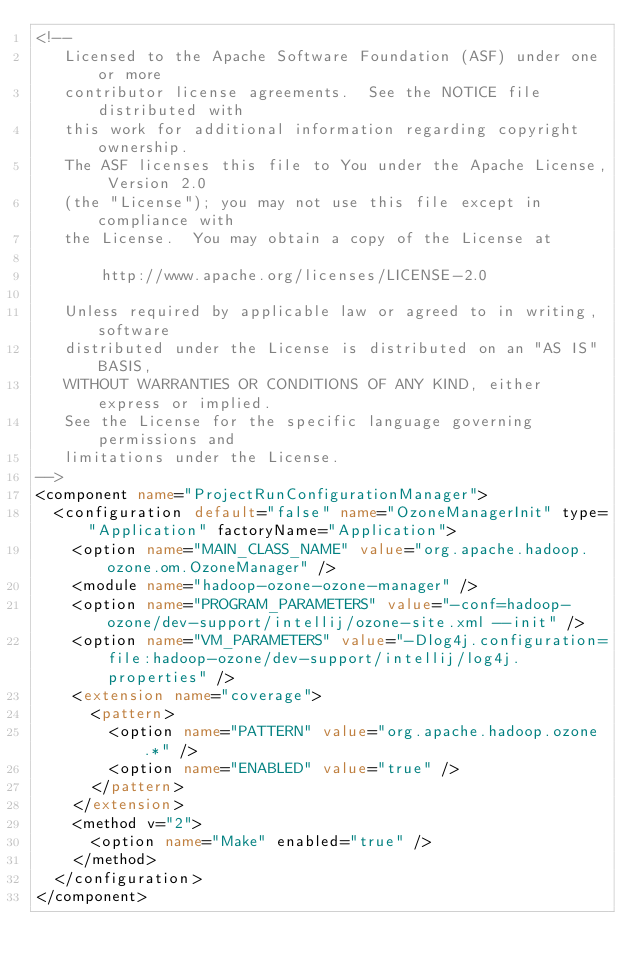<code> <loc_0><loc_0><loc_500><loc_500><_XML_><!--
   Licensed to the Apache Software Foundation (ASF) under one or more
   contributor license agreements.  See the NOTICE file distributed with
   this work for additional information regarding copyright ownership.
   The ASF licenses this file to You under the Apache License, Version 2.0
   (the "License"); you may not use this file except in compliance with
   the License.  You may obtain a copy of the License at

       http://www.apache.org/licenses/LICENSE-2.0

   Unless required by applicable law or agreed to in writing, software
   distributed under the License is distributed on an "AS IS" BASIS,
   WITHOUT WARRANTIES OR CONDITIONS OF ANY KIND, either express or implied.
   See the License for the specific language governing permissions and
   limitations under the License.
-->
<component name="ProjectRunConfigurationManager">
  <configuration default="false" name="OzoneManagerInit" type="Application" factoryName="Application">
    <option name="MAIN_CLASS_NAME" value="org.apache.hadoop.ozone.om.OzoneManager" />
    <module name="hadoop-ozone-ozone-manager" />
    <option name="PROGRAM_PARAMETERS" value="-conf=hadoop-ozone/dev-support/intellij/ozone-site.xml --init" />
    <option name="VM_PARAMETERS" value="-Dlog4j.configuration=file:hadoop-ozone/dev-support/intellij/log4j.properties" />
    <extension name="coverage">
      <pattern>
        <option name="PATTERN" value="org.apache.hadoop.ozone.*" />
        <option name="ENABLED" value="true" />
      </pattern>
    </extension>
    <method v="2">
      <option name="Make" enabled="true" />
    </method>
  </configuration>
</component></code> 